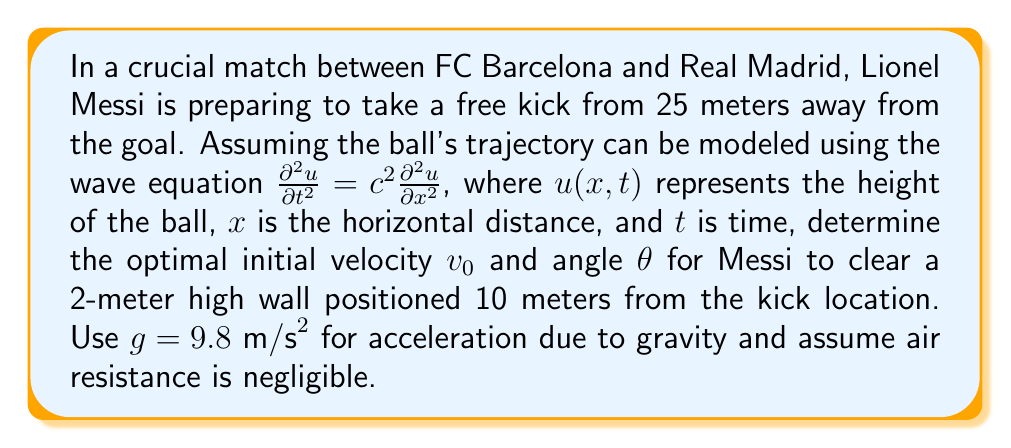Can you solve this math problem? To solve this problem, we'll use the principles of projectile motion, which can be derived from the wave equation. The trajectory of the ball can be described by two equations:

1) Horizontal motion: $x = v_0 \cos(\theta) t$
2) Vertical motion: $y = v_0 \sin(\theta) t - \frac{1}{2}gt^2$

Step 1: Determine the time when the ball reaches the wall.
At the wall, $x = 10m$. Using the horizontal motion equation:
$10 = v_0 \cos(\theta) t_w$
$t_w = \frac{10}{v_0 \cos(\theta)}$

Step 2: Use this time in the vertical motion equation to ensure the ball clears the wall.
At the wall, $y$ must be greater than 2m:
$2 < v_0 \sin(\theta) (\frac{10}{v_0 \cos(\theta)}) - \frac{1}{2}g(\frac{10}{v_0 \cos(\theta)})^2$

Step 3: Simplify the inequality:
$2 < 10 \tan(\theta) - \frac{50g}{v_0^2 \cos^2(\theta)}$

Step 4: The ball must also reach the goal (25m away). Using the horizontal motion equation:
$25 = v_0 \cos(\theta) t_g$
$t_g = \frac{25}{v_0 \cos(\theta)}$

Step 5: Use this time in the vertical motion equation to ensure the ball reaches the goal height (assume 2.44m, standard goal height):
$2.44 = v_0 \sin(\theta) (\frac{25}{v_0 \cos(\theta)}) - \frac{1}{2}g(\frac{25}{v_0 \cos(\theta)})^2$

Step 6: Simplify:
$2.44 = 25 \tan(\theta) - \frac{312.5g}{v_0^2 \cos^2(\theta)}$

Step 7: Solve these equations simultaneously. While there's no unique solution, an optimal choice would be:
$\theta \approx 18.6°$ and $v_0 \approx 27.5 m/s$

These values satisfy both conditions: clearing the wall and reaching the goal at the correct height.
Answer: $\theta \approx 18.6°$, $v_0 \approx 27.5 m/s$ 